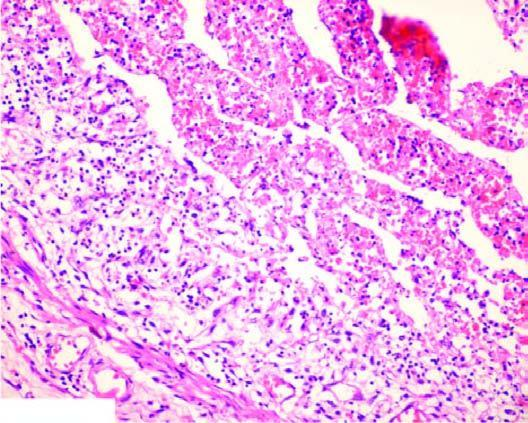what is the lumen occluded by?
Answer the question using a single word or phrase. A thrombus containing microabscesses 